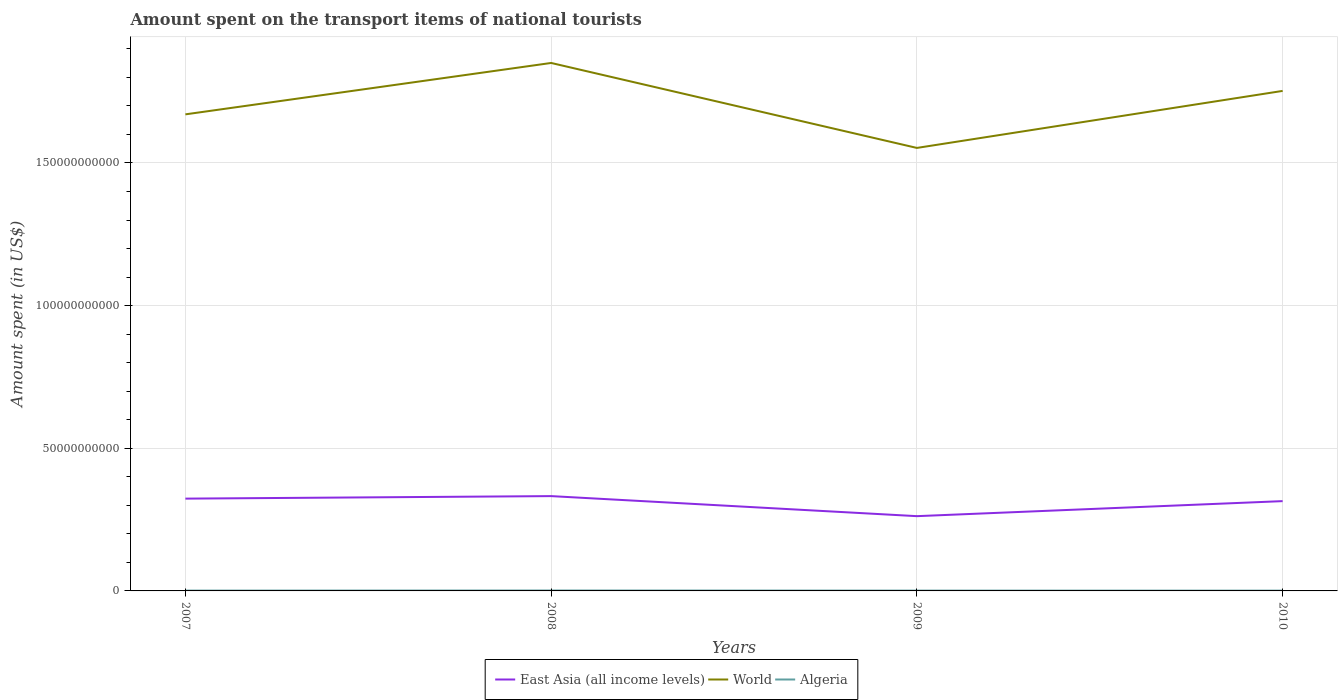How many different coloured lines are there?
Offer a terse response. 3. Is the number of lines equal to the number of legend labels?
Ensure brevity in your answer.  Yes. Across all years, what is the maximum amount spent on the transport items of national tourists in Algeria?
Keep it short and to the point. 1.04e+08. In which year was the amount spent on the transport items of national tourists in East Asia (all income levels) maximum?
Provide a short and direct response. 2009. What is the total amount spent on the transport items of national tourists in Algeria in the graph?
Your response must be concise. 4.60e+07. What is the difference between the highest and the second highest amount spent on the transport items of national tourists in East Asia (all income levels)?
Offer a terse response. 7.03e+09. How many lines are there?
Offer a very short reply. 3. How many years are there in the graph?
Provide a short and direct response. 4. Does the graph contain grids?
Provide a succinct answer. Yes. Where does the legend appear in the graph?
Provide a short and direct response. Bottom center. How are the legend labels stacked?
Ensure brevity in your answer.  Horizontal. What is the title of the graph?
Offer a terse response. Amount spent on the transport items of national tourists. Does "Middle East & North Africa (all income levels)" appear as one of the legend labels in the graph?
Make the answer very short. No. What is the label or title of the X-axis?
Offer a terse response. Years. What is the label or title of the Y-axis?
Provide a short and direct response. Amount spent (in US$). What is the Amount spent (in US$) in East Asia (all income levels) in 2007?
Ensure brevity in your answer.  3.24e+1. What is the Amount spent (in US$) in World in 2007?
Offer a very short reply. 1.67e+11. What is the Amount spent (in US$) in Algeria in 2007?
Ensure brevity in your answer.  1.15e+08. What is the Amount spent (in US$) in East Asia (all income levels) in 2008?
Your answer should be very brief. 3.32e+1. What is the Amount spent (in US$) of World in 2008?
Ensure brevity in your answer.  1.85e+11. What is the Amount spent (in US$) in Algeria in 2008?
Your answer should be compact. 1.50e+08. What is the Amount spent (in US$) in East Asia (all income levels) in 2009?
Your answer should be compact. 2.62e+1. What is the Amount spent (in US$) in World in 2009?
Offer a very short reply. 1.55e+11. What is the Amount spent (in US$) in Algeria in 2009?
Offer a terse response. 1.15e+08. What is the Amount spent (in US$) of East Asia (all income levels) in 2010?
Your response must be concise. 3.15e+1. What is the Amount spent (in US$) of World in 2010?
Ensure brevity in your answer.  1.75e+11. What is the Amount spent (in US$) in Algeria in 2010?
Offer a terse response. 1.04e+08. Across all years, what is the maximum Amount spent (in US$) in East Asia (all income levels)?
Provide a succinct answer. 3.32e+1. Across all years, what is the maximum Amount spent (in US$) of World?
Provide a succinct answer. 1.85e+11. Across all years, what is the maximum Amount spent (in US$) in Algeria?
Offer a very short reply. 1.50e+08. Across all years, what is the minimum Amount spent (in US$) of East Asia (all income levels)?
Your answer should be very brief. 2.62e+1. Across all years, what is the minimum Amount spent (in US$) of World?
Your answer should be very brief. 1.55e+11. Across all years, what is the minimum Amount spent (in US$) in Algeria?
Your answer should be compact. 1.04e+08. What is the total Amount spent (in US$) of East Asia (all income levels) in the graph?
Ensure brevity in your answer.  1.23e+11. What is the total Amount spent (in US$) of World in the graph?
Give a very brief answer. 6.83e+11. What is the total Amount spent (in US$) of Algeria in the graph?
Offer a terse response. 4.84e+08. What is the difference between the Amount spent (in US$) of East Asia (all income levels) in 2007 and that in 2008?
Provide a succinct answer. -8.82e+08. What is the difference between the Amount spent (in US$) in World in 2007 and that in 2008?
Your answer should be compact. -1.80e+1. What is the difference between the Amount spent (in US$) in Algeria in 2007 and that in 2008?
Your response must be concise. -3.50e+07. What is the difference between the Amount spent (in US$) of East Asia (all income levels) in 2007 and that in 2009?
Your response must be concise. 6.15e+09. What is the difference between the Amount spent (in US$) in World in 2007 and that in 2009?
Your response must be concise. 1.18e+1. What is the difference between the Amount spent (in US$) in Algeria in 2007 and that in 2009?
Give a very brief answer. 0. What is the difference between the Amount spent (in US$) in East Asia (all income levels) in 2007 and that in 2010?
Provide a short and direct response. 8.75e+08. What is the difference between the Amount spent (in US$) of World in 2007 and that in 2010?
Your answer should be compact. -8.22e+09. What is the difference between the Amount spent (in US$) in Algeria in 2007 and that in 2010?
Your answer should be very brief. 1.10e+07. What is the difference between the Amount spent (in US$) in East Asia (all income levels) in 2008 and that in 2009?
Offer a terse response. 7.03e+09. What is the difference between the Amount spent (in US$) in World in 2008 and that in 2009?
Provide a succinct answer. 2.98e+1. What is the difference between the Amount spent (in US$) of Algeria in 2008 and that in 2009?
Provide a short and direct response. 3.50e+07. What is the difference between the Amount spent (in US$) of East Asia (all income levels) in 2008 and that in 2010?
Make the answer very short. 1.76e+09. What is the difference between the Amount spent (in US$) in World in 2008 and that in 2010?
Your answer should be compact. 9.80e+09. What is the difference between the Amount spent (in US$) in Algeria in 2008 and that in 2010?
Offer a very short reply. 4.60e+07. What is the difference between the Amount spent (in US$) in East Asia (all income levels) in 2009 and that in 2010?
Provide a short and direct response. -5.27e+09. What is the difference between the Amount spent (in US$) in World in 2009 and that in 2010?
Provide a succinct answer. -2.00e+1. What is the difference between the Amount spent (in US$) in Algeria in 2009 and that in 2010?
Offer a terse response. 1.10e+07. What is the difference between the Amount spent (in US$) of East Asia (all income levels) in 2007 and the Amount spent (in US$) of World in 2008?
Make the answer very short. -1.53e+11. What is the difference between the Amount spent (in US$) in East Asia (all income levels) in 2007 and the Amount spent (in US$) in Algeria in 2008?
Provide a succinct answer. 3.22e+1. What is the difference between the Amount spent (in US$) of World in 2007 and the Amount spent (in US$) of Algeria in 2008?
Provide a short and direct response. 1.67e+11. What is the difference between the Amount spent (in US$) of East Asia (all income levels) in 2007 and the Amount spent (in US$) of World in 2009?
Provide a short and direct response. -1.23e+11. What is the difference between the Amount spent (in US$) of East Asia (all income levels) in 2007 and the Amount spent (in US$) of Algeria in 2009?
Provide a short and direct response. 3.22e+1. What is the difference between the Amount spent (in US$) in World in 2007 and the Amount spent (in US$) in Algeria in 2009?
Provide a short and direct response. 1.67e+11. What is the difference between the Amount spent (in US$) in East Asia (all income levels) in 2007 and the Amount spent (in US$) in World in 2010?
Offer a terse response. -1.43e+11. What is the difference between the Amount spent (in US$) of East Asia (all income levels) in 2007 and the Amount spent (in US$) of Algeria in 2010?
Provide a succinct answer. 3.22e+1. What is the difference between the Amount spent (in US$) of World in 2007 and the Amount spent (in US$) of Algeria in 2010?
Offer a terse response. 1.67e+11. What is the difference between the Amount spent (in US$) in East Asia (all income levels) in 2008 and the Amount spent (in US$) in World in 2009?
Offer a terse response. -1.22e+11. What is the difference between the Amount spent (in US$) of East Asia (all income levels) in 2008 and the Amount spent (in US$) of Algeria in 2009?
Provide a short and direct response. 3.31e+1. What is the difference between the Amount spent (in US$) of World in 2008 and the Amount spent (in US$) of Algeria in 2009?
Provide a succinct answer. 1.85e+11. What is the difference between the Amount spent (in US$) in East Asia (all income levels) in 2008 and the Amount spent (in US$) in World in 2010?
Provide a succinct answer. -1.42e+11. What is the difference between the Amount spent (in US$) in East Asia (all income levels) in 2008 and the Amount spent (in US$) in Algeria in 2010?
Provide a succinct answer. 3.31e+1. What is the difference between the Amount spent (in US$) in World in 2008 and the Amount spent (in US$) in Algeria in 2010?
Your answer should be very brief. 1.85e+11. What is the difference between the Amount spent (in US$) of East Asia (all income levels) in 2009 and the Amount spent (in US$) of World in 2010?
Your answer should be compact. -1.49e+11. What is the difference between the Amount spent (in US$) in East Asia (all income levels) in 2009 and the Amount spent (in US$) in Algeria in 2010?
Ensure brevity in your answer.  2.61e+1. What is the difference between the Amount spent (in US$) of World in 2009 and the Amount spent (in US$) of Algeria in 2010?
Keep it short and to the point. 1.55e+11. What is the average Amount spent (in US$) of East Asia (all income levels) per year?
Give a very brief answer. 3.08e+1. What is the average Amount spent (in US$) of World per year?
Offer a very short reply. 1.71e+11. What is the average Amount spent (in US$) of Algeria per year?
Give a very brief answer. 1.21e+08. In the year 2007, what is the difference between the Amount spent (in US$) of East Asia (all income levels) and Amount spent (in US$) of World?
Keep it short and to the point. -1.35e+11. In the year 2007, what is the difference between the Amount spent (in US$) in East Asia (all income levels) and Amount spent (in US$) in Algeria?
Give a very brief answer. 3.22e+1. In the year 2007, what is the difference between the Amount spent (in US$) of World and Amount spent (in US$) of Algeria?
Provide a short and direct response. 1.67e+11. In the year 2008, what is the difference between the Amount spent (in US$) in East Asia (all income levels) and Amount spent (in US$) in World?
Provide a succinct answer. -1.52e+11. In the year 2008, what is the difference between the Amount spent (in US$) of East Asia (all income levels) and Amount spent (in US$) of Algeria?
Your answer should be compact. 3.31e+1. In the year 2008, what is the difference between the Amount spent (in US$) in World and Amount spent (in US$) in Algeria?
Give a very brief answer. 1.85e+11. In the year 2009, what is the difference between the Amount spent (in US$) in East Asia (all income levels) and Amount spent (in US$) in World?
Provide a succinct answer. -1.29e+11. In the year 2009, what is the difference between the Amount spent (in US$) in East Asia (all income levels) and Amount spent (in US$) in Algeria?
Provide a succinct answer. 2.61e+1. In the year 2009, what is the difference between the Amount spent (in US$) of World and Amount spent (in US$) of Algeria?
Make the answer very short. 1.55e+11. In the year 2010, what is the difference between the Amount spent (in US$) in East Asia (all income levels) and Amount spent (in US$) in World?
Your answer should be compact. -1.44e+11. In the year 2010, what is the difference between the Amount spent (in US$) of East Asia (all income levels) and Amount spent (in US$) of Algeria?
Your answer should be very brief. 3.14e+1. In the year 2010, what is the difference between the Amount spent (in US$) in World and Amount spent (in US$) in Algeria?
Your response must be concise. 1.75e+11. What is the ratio of the Amount spent (in US$) of East Asia (all income levels) in 2007 to that in 2008?
Your response must be concise. 0.97. What is the ratio of the Amount spent (in US$) in World in 2007 to that in 2008?
Your answer should be very brief. 0.9. What is the ratio of the Amount spent (in US$) in Algeria in 2007 to that in 2008?
Your answer should be very brief. 0.77. What is the ratio of the Amount spent (in US$) of East Asia (all income levels) in 2007 to that in 2009?
Your answer should be very brief. 1.23. What is the ratio of the Amount spent (in US$) of World in 2007 to that in 2009?
Provide a short and direct response. 1.08. What is the ratio of the Amount spent (in US$) in East Asia (all income levels) in 2007 to that in 2010?
Ensure brevity in your answer.  1.03. What is the ratio of the Amount spent (in US$) of World in 2007 to that in 2010?
Provide a short and direct response. 0.95. What is the ratio of the Amount spent (in US$) in Algeria in 2007 to that in 2010?
Provide a short and direct response. 1.11. What is the ratio of the Amount spent (in US$) of East Asia (all income levels) in 2008 to that in 2009?
Your answer should be very brief. 1.27. What is the ratio of the Amount spent (in US$) in World in 2008 to that in 2009?
Your response must be concise. 1.19. What is the ratio of the Amount spent (in US$) in Algeria in 2008 to that in 2009?
Your response must be concise. 1.3. What is the ratio of the Amount spent (in US$) in East Asia (all income levels) in 2008 to that in 2010?
Ensure brevity in your answer.  1.06. What is the ratio of the Amount spent (in US$) of World in 2008 to that in 2010?
Your response must be concise. 1.06. What is the ratio of the Amount spent (in US$) in Algeria in 2008 to that in 2010?
Make the answer very short. 1.44. What is the ratio of the Amount spent (in US$) of East Asia (all income levels) in 2009 to that in 2010?
Provide a short and direct response. 0.83. What is the ratio of the Amount spent (in US$) of World in 2009 to that in 2010?
Provide a succinct answer. 0.89. What is the ratio of the Amount spent (in US$) in Algeria in 2009 to that in 2010?
Your answer should be compact. 1.11. What is the difference between the highest and the second highest Amount spent (in US$) in East Asia (all income levels)?
Provide a short and direct response. 8.82e+08. What is the difference between the highest and the second highest Amount spent (in US$) in World?
Your response must be concise. 9.80e+09. What is the difference between the highest and the second highest Amount spent (in US$) of Algeria?
Your answer should be compact. 3.50e+07. What is the difference between the highest and the lowest Amount spent (in US$) of East Asia (all income levels)?
Ensure brevity in your answer.  7.03e+09. What is the difference between the highest and the lowest Amount spent (in US$) of World?
Make the answer very short. 2.98e+1. What is the difference between the highest and the lowest Amount spent (in US$) in Algeria?
Provide a short and direct response. 4.60e+07. 